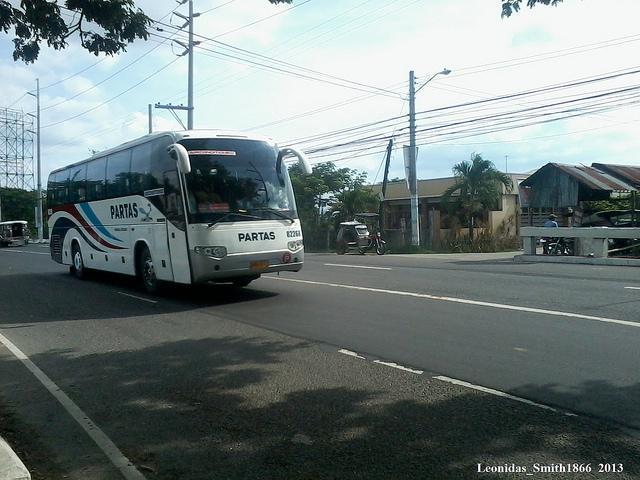How many buses are there?
Give a very brief answer. 1. How many buses can be seen?
Give a very brief answer. 1. How many buses?
Give a very brief answer. 1. How many slices of pizza are left of the fork?
Give a very brief answer. 0. 